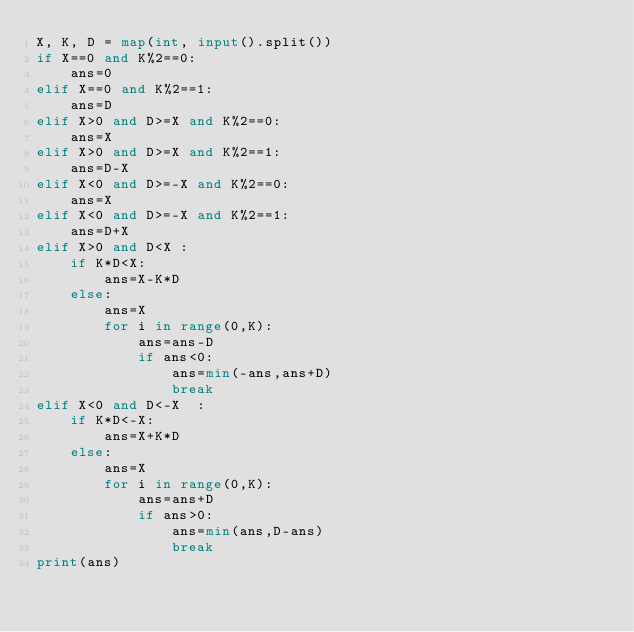Convert code to text. <code><loc_0><loc_0><loc_500><loc_500><_Python_>X, K, D = map(int, input().split())
if X==0 and K%2==0:
    ans=0
elif X==0 and K%2==1:
    ans=D
elif X>0 and D>=X and K%2==0:
    ans=X
elif X>0 and D>=X and K%2==1:
    ans=D-X
elif X<0 and D>=-X and K%2==0:
    ans=X
elif X<0 and D>=-X and K%2==1:
    ans=D+X
elif X>0 and D<X :
    if K*D<X:
        ans=X-K*D
    else:
        ans=X
        for i in range(0,K):
            ans=ans-D
            if ans<0:
                ans=min(-ans,ans+D)
                break
elif X<0 and D<-X  :
    if K*D<-X:
        ans=X+K*D
    else:
        ans=X
        for i in range(0,K):
            ans=ans+D
            if ans>0:
                ans=min(ans,D-ans)
                break
print(ans)</code> 